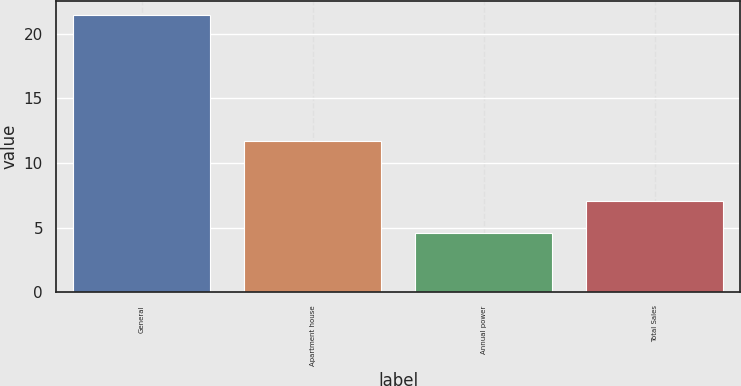Convert chart to OTSL. <chart><loc_0><loc_0><loc_500><loc_500><bar_chart><fcel>General<fcel>Apartment house<fcel>Annual power<fcel>Total Sales<nl><fcel>21.5<fcel>11.7<fcel>4.6<fcel>7.1<nl></chart> 